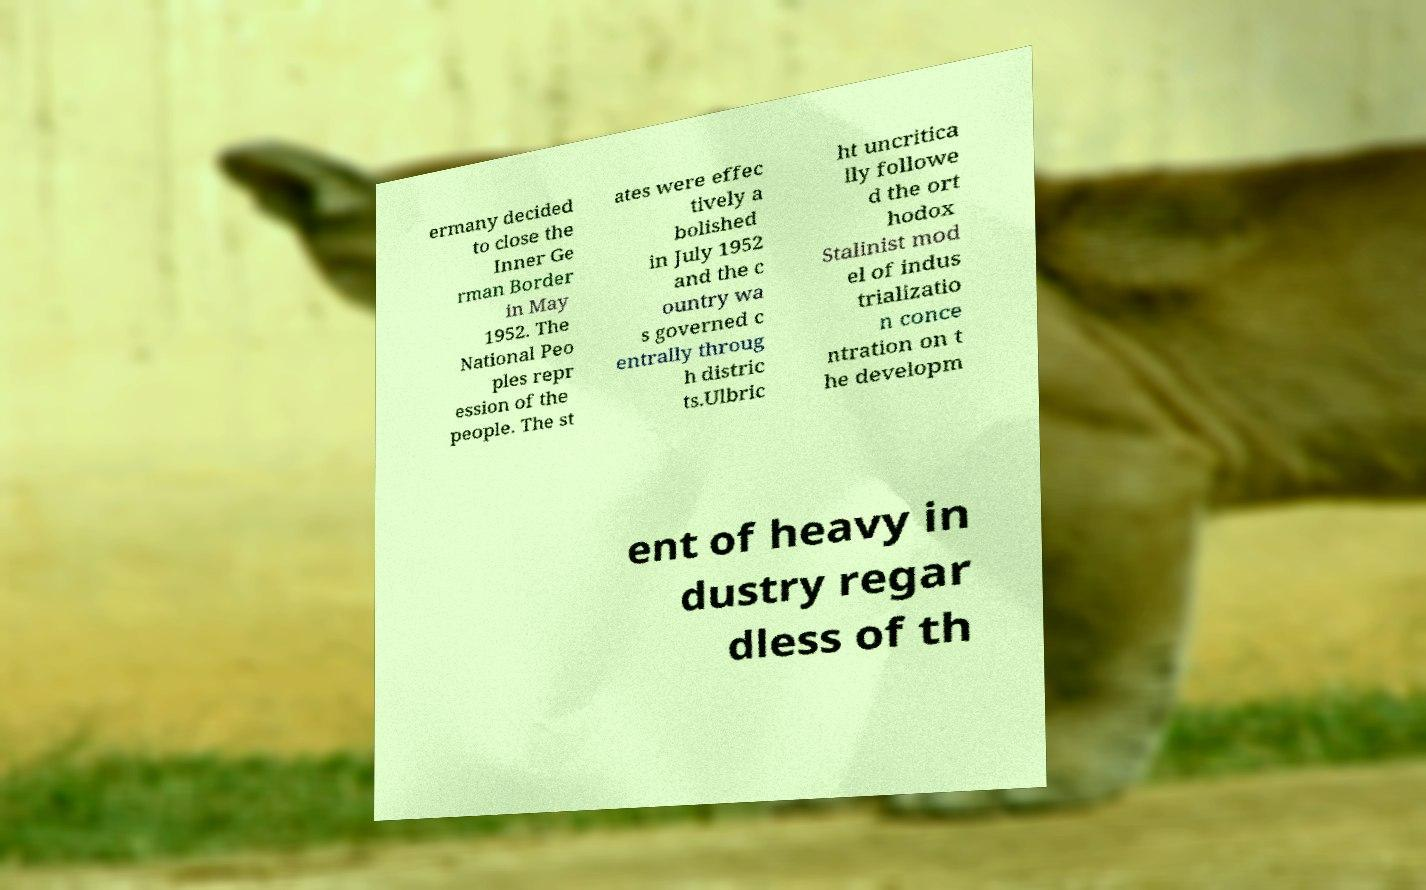What messages or text are displayed in this image? I need them in a readable, typed format. ermany decided to close the Inner Ge rman Border in May 1952. The National Peo ples repr ession of the people. The st ates were effec tively a bolished in July 1952 and the c ountry wa s governed c entrally throug h distric ts.Ulbric ht uncritica lly followe d the ort hodox Stalinist mod el of indus trializatio n conce ntration on t he developm ent of heavy in dustry regar dless of th 